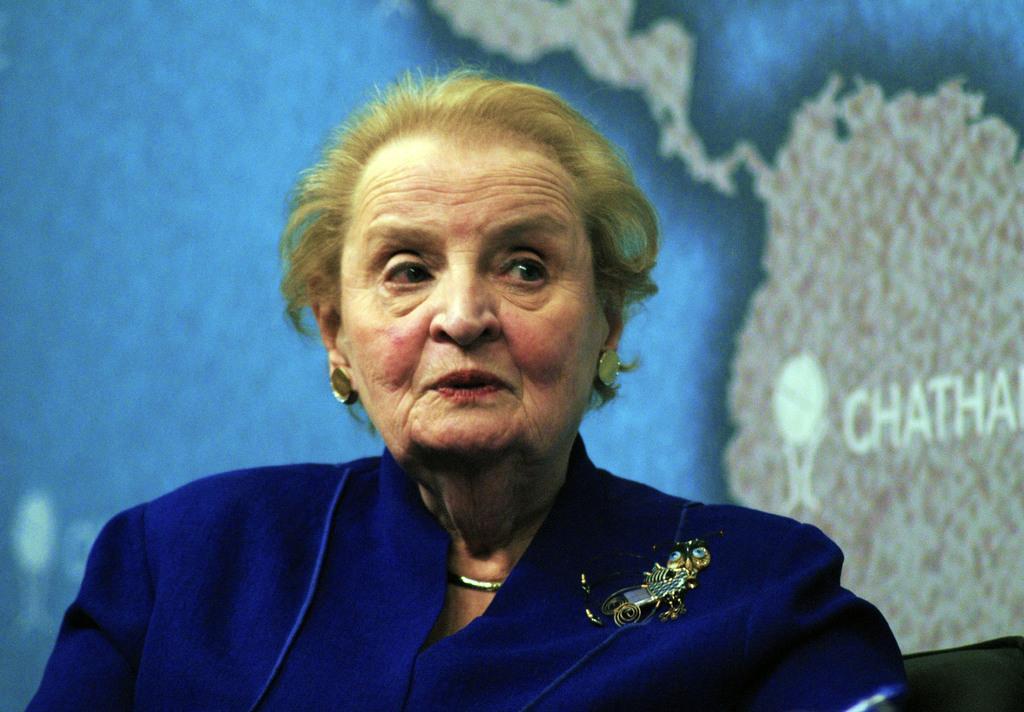Describe this image in one or two sentences. In the image we can see there is a woman. Behind on the wall there is a poster of a map. 